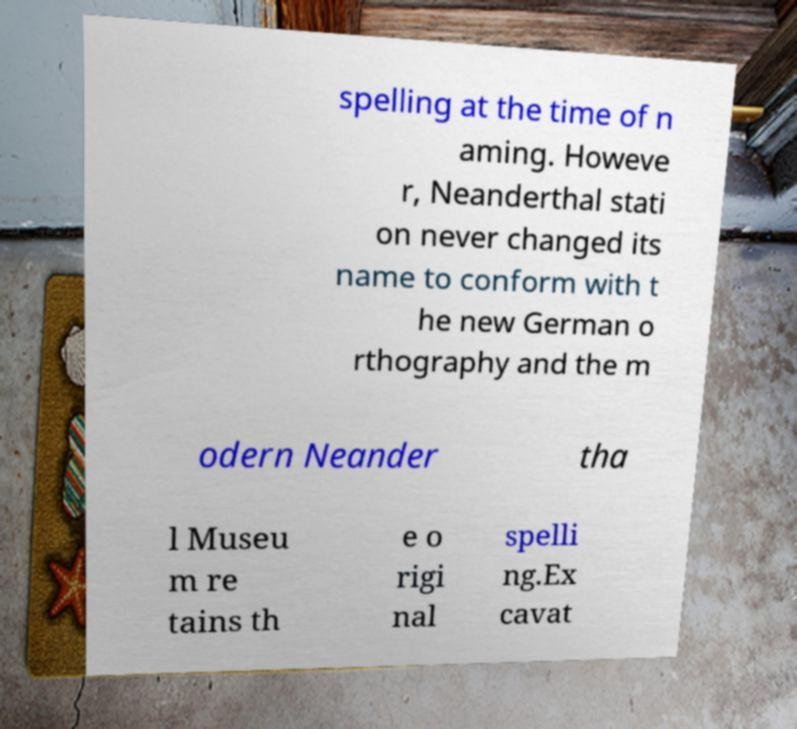I need the written content from this picture converted into text. Can you do that? spelling at the time of n aming. Howeve r, Neanderthal stati on never changed its name to conform with t he new German o rthography and the m odern Neander tha l Museu m re tains th e o rigi nal spelli ng.Ex cavat 